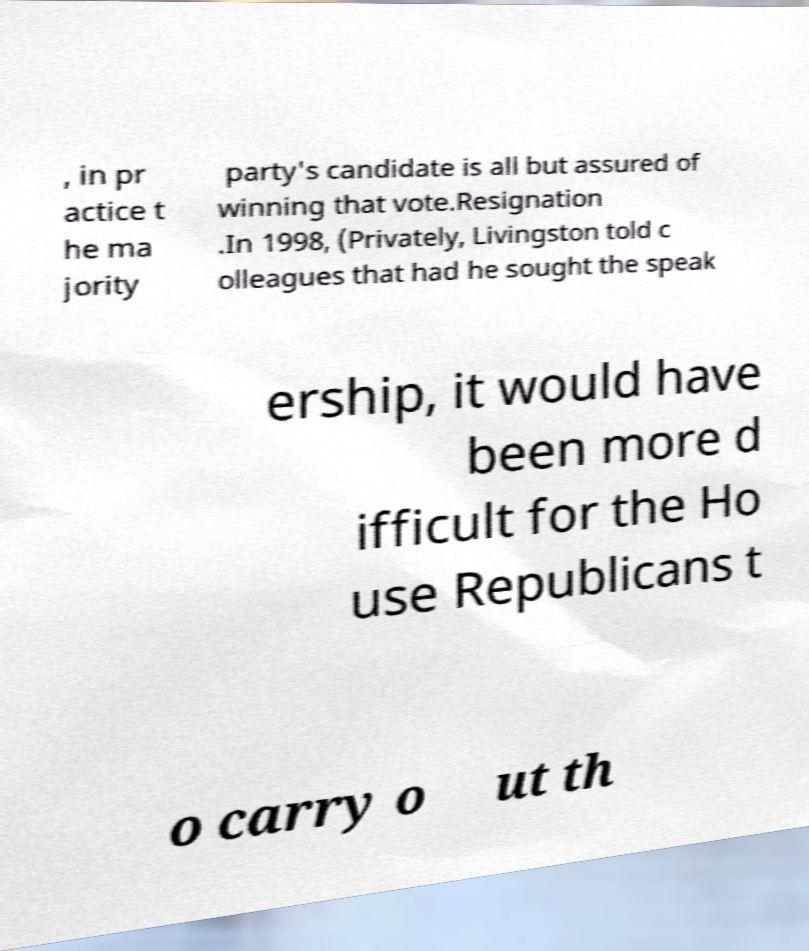Could you extract and type out the text from this image? , in pr actice t he ma jority party's candidate is all but assured of winning that vote.Resignation .In 1998, (Privately, Livingston told c olleagues that had he sought the speak ership, it would have been more d ifficult for the Ho use Republicans t o carry o ut th 